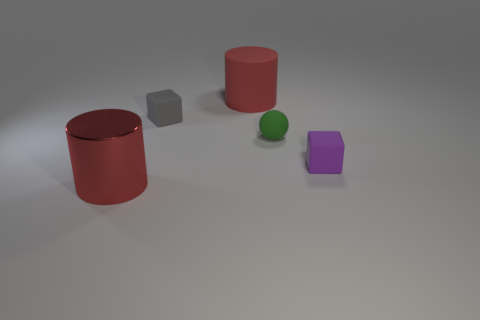What color is the shiny cylinder?
Your answer should be very brief. Red. Does the metallic cylinder have the same size as the green thing?
Ensure brevity in your answer.  No. Is there any other thing that is the same shape as the big matte object?
Your answer should be compact. Yes. Do the purple cube and the cylinder that is behind the metal cylinder have the same material?
Make the answer very short. Yes. There is a cylinder that is on the left side of the big matte thing; does it have the same color as the sphere?
Your response must be concise. No. How many rubber things are both in front of the tiny gray cube and behind the gray cube?
Your answer should be compact. 0. How many other objects are there of the same material as the green thing?
Give a very brief answer. 3. Does the large red thing that is in front of the small purple rubber thing have the same material as the tiny purple thing?
Keep it short and to the point. No. There is a red object that is to the right of the big object that is in front of the small cube in front of the green rubber object; how big is it?
Your answer should be compact. Large. What number of other objects are there of the same color as the tiny rubber sphere?
Ensure brevity in your answer.  0. 